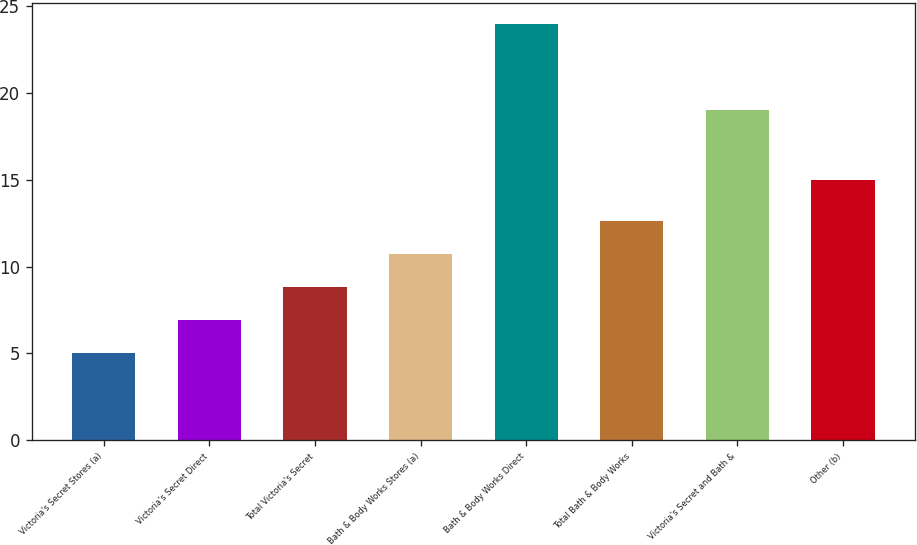Convert chart to OTSL. <chart><loc_0><loc_0><loc_500><loc_500><bar_chart><fcel>Victoria's Secret Stores (a)<fcel>Victoria's Secret Direct<fcel>Total Victoria's Secret<fcel>Bath & Body Works Stores (a)<fcel>Bath & Body Works Direct<fcel>Total Bath & Body Works<fcel>Victoria's Secret and Bath &<fcel>Other (b)<nl><fcel>5<fcel>6.9<fcel>8.8<fcel>10.7<fcel>24<fcel>12.6<fcel>19<fcel>15<nl></chart> 